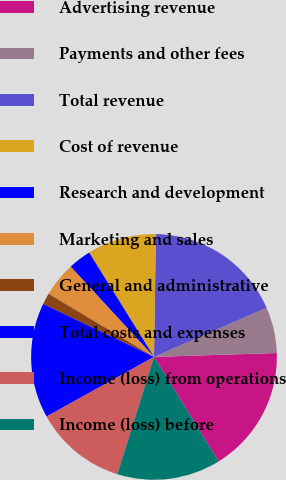Convert chart to OTSL. <chart><loc_0><loc_0><loc_500><loc_500><pie_chart><fcel>Advertising revenue<fcel>Payments and other fees<fcel>Total revenue<fcel>Cost of revenue<fcel>Research and development<fcel>Marketing and sales<fcel>General and administrative<fcel>Total costs and expenses<fcel>Income (loss) from operations<fcel>Income (loss) before<nl><fcel>16.68%<fcel>6.05%<fcel>18.2%<fcel>9.09%<fcel>3.02%<fcel>4.54%<fcel>1.5%<fcel>15.16%<fcel>12.12%<fcel>13.64%<nl></chart> 